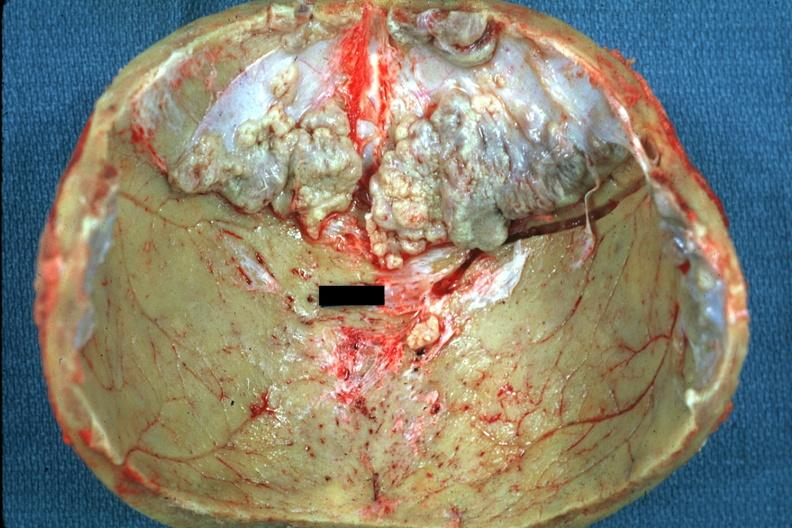s exostosis present?
Answer the question using a single word or phrase. Yes 